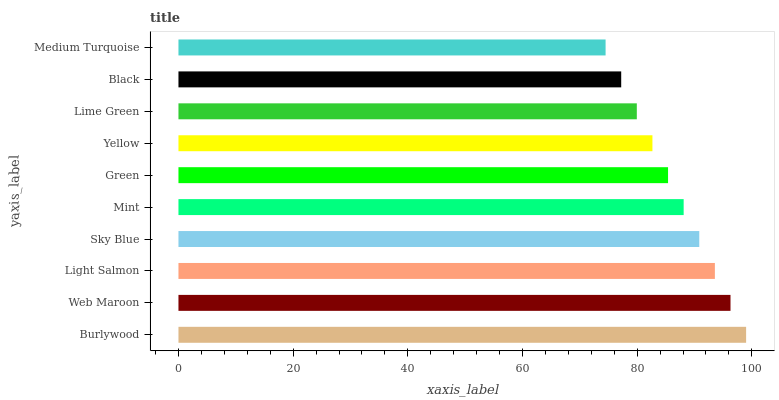Is Medium Turquoise the minimum?
Answer yes or no. Yes. Is Burlywood the maximum?
Answer yes or no. Yes. Is Web Maroon the minimum?
Answer yes or no. No. Is Web Maroon the maximum?
Answer yes or no. No. Is Burlywood greater than Web Maroon?
Answer yes or no. Yes. Is Web Maroon less than Burlywood?
Answer yes or no. Yes. Is Web Maroon greater than Burlywood?
Answer yes or no. No. Is Burlywood less than Web Maroon?
Answer yes or no. No. Is Mint the high median?
Answer yes or no. Yes. Is Green the low median?
Answer yes or no. Yes. Is Light Salmon the high median?
Answer yes or no. No. Is Yellow the low median?
Answer yes or no. No. 